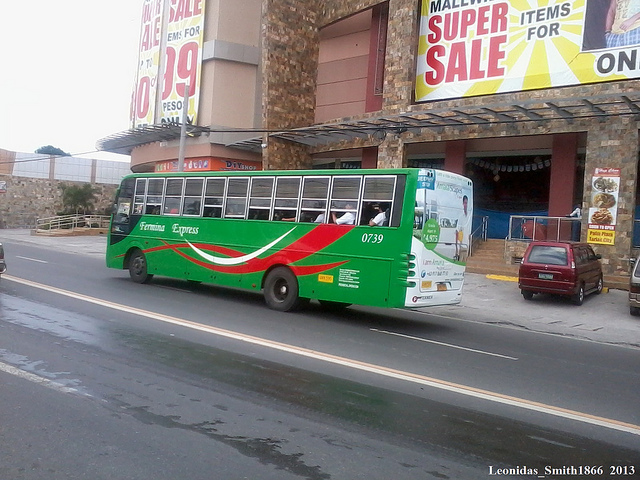Identify the text contained in this image. Epress 0739 SUPER SALE ITE FOR ON 2013 18 Leonidas_Smith FESO 99 0 FOR EM SALE 